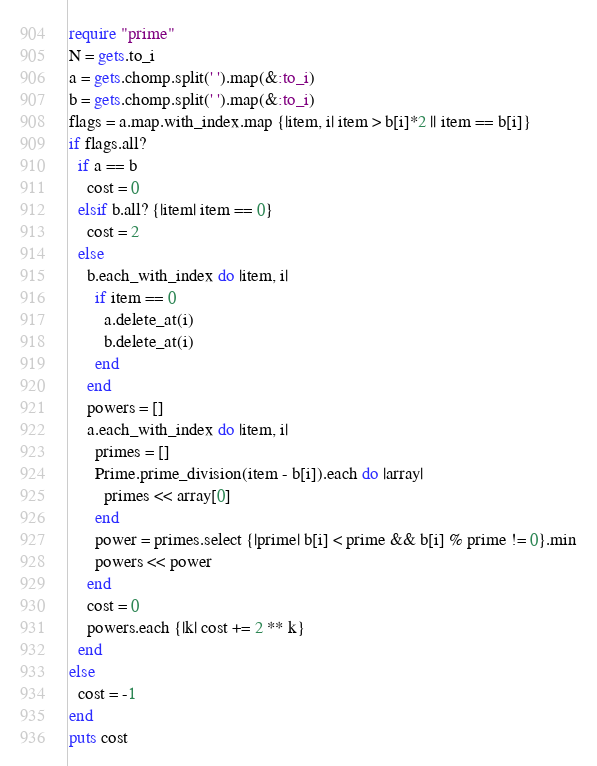<code> <loc_0><loc_0><loc_500><loc_500><_Ruby_>require "prime"
N = gets.to_i
a = gets.chomp.split(' ').map(&:to_i)
b = gets.chomp.split(' ').map(&:to_i)
flags = a.map.with_index.map {|item, i| item > b[i]*2 || item == b[i]}
if flags.all?
  if a == b
    cost = 0
  elsif b.all? {|item| item == 0}
    cost = 2
  else
    b.each_with_index do |item, i|
      if item == 0
        a.delete_at(i)
        b.delete_at(i)
      end
    end
    powers = []
    a.each_with_index do |item, i|
      primes = []
      Prime.prime_division(item - b[i]).each do |array|
        primes << array[0]
      end
      power = primes.select {|prime| b[i] < prime && b[i] % prime != 0}.min
      powers << power
    end
    cost = 0
    powers.each {|k| cost += 2 ** k}
  end
else
  cost = -1
end
puts cost
</code> 